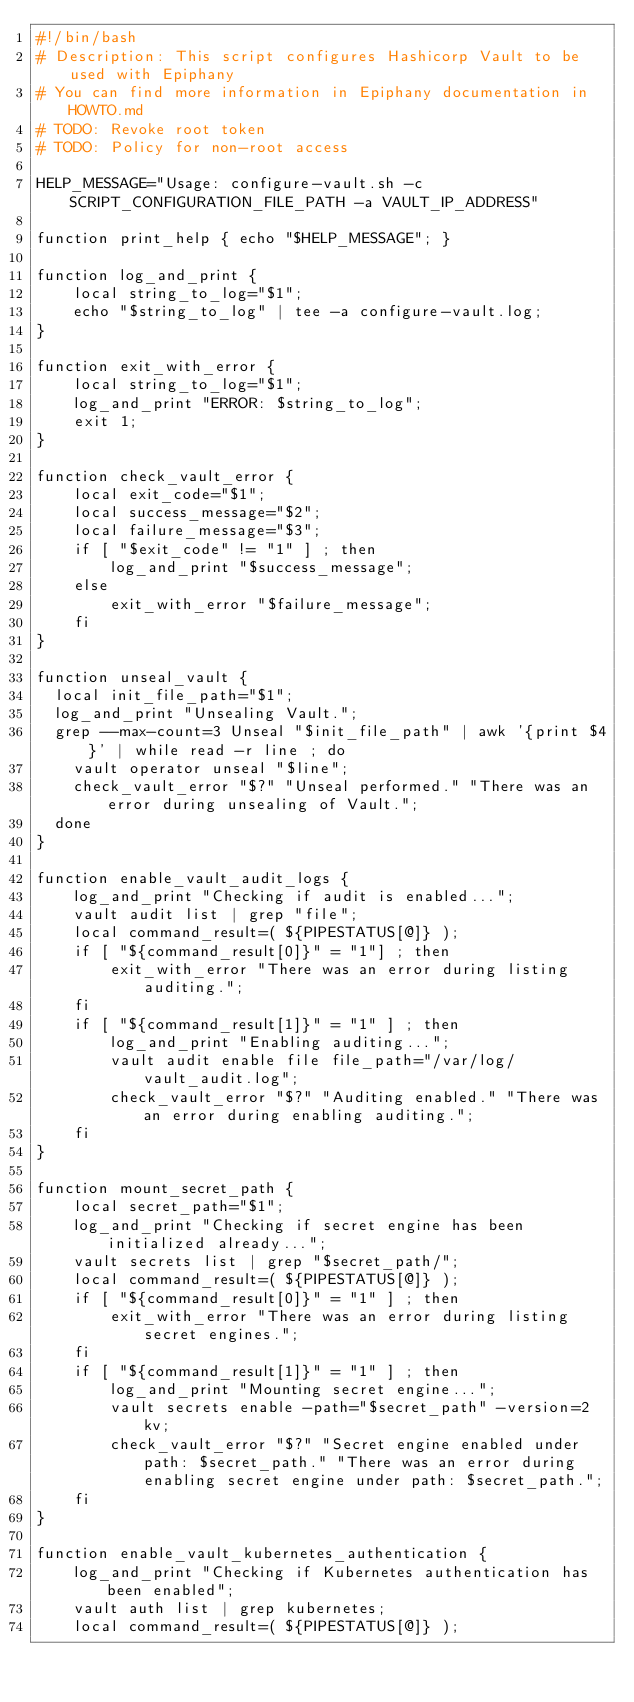<code> <loc_0><loc_0><loc_500><loc_500><_Bash_>#!/bin/bash
# Description: This script configures Hashicorp Vault to be used with Epiphany
# You can find more information in Epiphany documentation in HOWTO.md
# TODO: Revoke root token
# TODO: Policy for non-root access

HELP_MESSAGE="Usage: configure-vault.sh -c SCRIPT_CONFIGURATION_FILE_PATH -a VAULT_IP_ADDRESS"

function print_help { echo "$HELP_MESSAGE"; }

function log_and_print {
    local string_to_log="$1";
    echo "$string_to_log" | tee -a configure-vault.log;
}

function exit_with_error {
    local string_to_log="$1";
    log_and_print "ERROR: $string_to_log";
    exit 1;
}

function check_vault_error {
    local exit_code="$1";
    local success_message="$2";
    local failure_message="$3";
    if [ "$exit_code" != "1" ] ; then
        log_and_print "$success_message";
    else
        exit_with_error "$failure_message";
    fi
}

function unseal_vault {
  local init_file_path="$1";
  log_and_print "Unsealing Vault.";
  grep --max-count=3 Unseal "$init_file_path" | awk '{print $4}' | while read -r line ; do
    vault operator unseal "$line";
    check_vault_error "$?" "Unseal performed." "There was an error during unsealing of Vault.";
  done
}

function enable_vault_audit_logs {
    log_and_print "Checking if audit is enabled...";
    vault audit list | grep "file";
    local command_result=( ${PIPESTATUS[@]} );
    if [ "${command_result[0]}" = "1"] ; then
        exit_with_error "There was an error during listing auditing.";
    fi
    if [ "${command_result[1]}" = "1" ] ; then
        log_and_print "Enabling auditing...";
        vault audit enable file file_path="/var/log/vault_audit.log";
        check_vault_error "$?" "Auditing enabled." "There was an error during enabling auditing.";
    fi
}

function mount_secret_path {
    local secret_path="$1";
    log_and_print "Checking if secret engine has been initialized already...";
    vault secrets list | grep "$secret_path/";
    local command_result=( ${PIPESTATUS[@]} );
    if [ "${command_result[0]}" = "1" ] ; then
        exit_with_error "There was an error during listing secret engines.";
    fi
    if [ "${command_result[1]}" = "1" ] ; then
        log_and_print "Mounting secret engine...";
        vault secrets enable -path="$secret_path" -version=2 kv;
        check_vault_error "$?" "Secret engine enabled under path: $secret_path." "There was an error during enabling secret engine under path: $secret_path.";
    fi
}

function enable_vault_kubernetes_authentication {
    log_and_print "Checking if Kubernetes authentication has been enabled";
    vault auth list | grep kubernetes;
    local command_result=( ${PIPESTATUS[@]} );</code> 